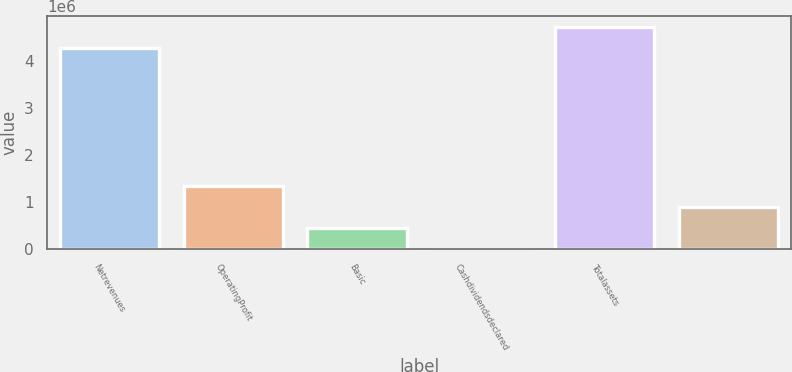Convert chart to OTSL. <chart><loc_0><loc_0><loc_500><loc_500><bar_chart><fcel>Netrevenues<fcel>OperatingProfit<fcel>Basic<fcel>Cashdividendsdeclared<fcel>Totalassets<fcel>Unnamed: 5<nl><fcel>4.27721e+06<fcel>1.35543e+06<fcel>451812<fcel>1.72<fcel>4.72902e+06<fcel>903621<nl></chart> 